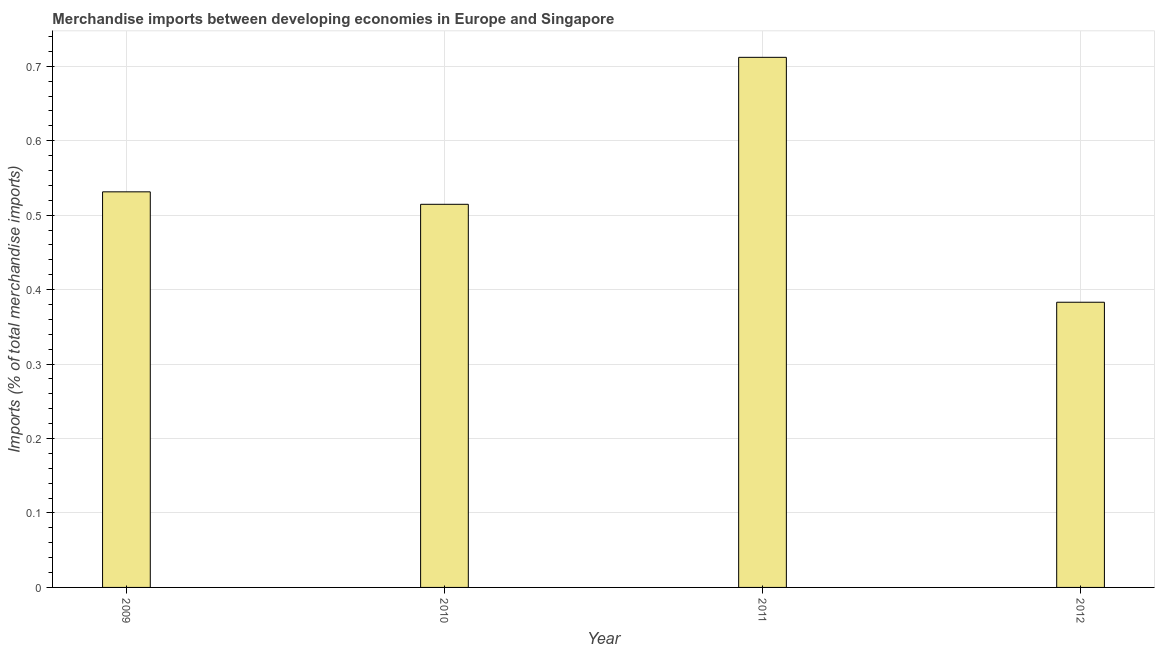Does the graph contain any zero values?
Give a very brief answer. No. Does the graph contain grids?
Offer a terse response. Yes. What is the title of the graph?
Your response must be concise. Merchandise imports between developing economies in Europe and Singapore. What is the label or title of the Y-axis?
Provide a short and direct response. Imports (% of total merchandise imports). What is the merchandise imports in 2011?
Give a very brief answer. 0.71. Across all years, what is the maximum merchandise imports?
Your answer should be very brief. 0.71. Across all years, what is the minimum merchandise imports?
Offer a terse response. 0.38. In which year was the merchandise imports maximum?
Ensure brevity in your answer.  2011. What is the sum of the merchandise imports?
Make the answer very short. 2.14. What is the difference between the merchandise imports in 2009 and 2011?
Provide a succinct answer. -0.18. What is the average merchandise imports per year?
Your response must be concise. 0.54. What is the median merchandise imports?
Offer a terse response. 0.52. In how many years, is the merchandise imports greater than 0.36 %?
Ensure brevity in your answer.  4. Do a majority of the years between 2010 and 2012 (inclusive) have merchandise imports greater than 0.02 %?
Offer a very short reply. Yes. What is the ratio of the merchandise imports in 2011 to that in 2012?
Give a very brief answer. 1.86. Is the difference between the merchandise imports in 2011 and 2012 greater than the difference between any two years?
Give a very brief answer. Yes. What is the difference between the highest and the second highest merchandise imports?
Ensure brevity in your answer.  0.18. Is the sum of the merchandise imports in 2009 and 2011 greater than the maximum merchandise imports across all years?
Give a very brief answer. Yes. What is the difference between the highest and the lowest merchandise imports?
Your response must be concise. 0.33. In how many years, is the merchandise imports greater than the average merchandise imports taken over all years?
Provide a short and direct response. 1. How many bars are there?
Keep it short and to the point. 4. Are all the bars in the graph horizontal?
Your answer should be very brief. No. What is the difference between two consecutive major ticks on the Y-axis?
Offer a terse response. 0.1. Are the values on the major ticks of Y-axis written in scientific E-notation?
Provide a short and direct response. No. What is the Imports (% of total merchandise imports) in 2009?
Provide a short and direct response. 0.53. What is the Imports (% of total merchandise imports) of 2010?
Provide a short and direct response. 0.51. What is the Imports (% of total merchandise imports) in 2011?
Give a very brief answer. 0.71. What is the Imports (% of total merchandise imports) of 2012?
Offer a terse response. 0.38. What is the difference between the Imports (% of total merchandise imports) in 2009 and 2010?
Your answer should be very brief. 0.02. What is the difference between the Imports (% of total merchandise imports) in 2009 and 2011?
Give a very brief answer. -0.18. What is the difference between the Imports (% of total merchandise imports) in 2009 and 2012?
Your answer should be compact. 0.15. What is the difference between the Imports (% of total merchandise imports) in 2010 and 2011?
Offer a terse response. -0.2. What is the difference between the Imports (% of total merchandise imports) in 2010 and 2012?
Your response must be concise. 0.13. What is the difference between the Imports (% of total merchandise imports) in 2011 and 2012?
Provide a short and direct response. 0.33. What is the ratio of the Imports (% of total merchandise imports) in 2009 to that in 2010?
Your answer should be compact. 1.03. What is the ratio of the Imports (% of total merchandise imports) in 2009 to that in 2011?
Your answer should be compact. 0.75. What is the ratio of the Imports (% of total merchandise imports) in 2009 to that in 2012?
Offer a terse response. 1.39. What is the ratio of the Imports (% of total merchandise imports) in 2010 to that in 2011?
Your answer should be compact. 0.72. What is the ratio of the Imports (% of total merchandise imports) in 2010 to that in 2012?
Your answer should be very brief. 1.34. What is the ratio of the Imports (% of total merchandise imports) in 2011 to that in 2012?
Ensure brevity in your answer.  1.86. 